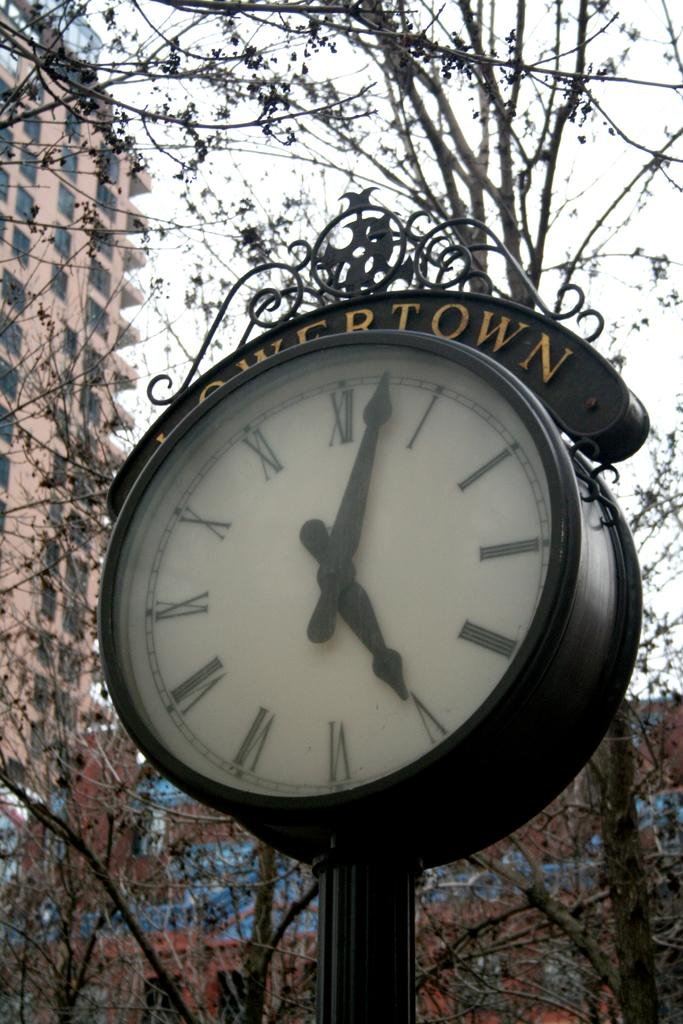<image>
Offer a succinct explanation of the picture presented. A clock in the middle of a city says Lowertown on it. 